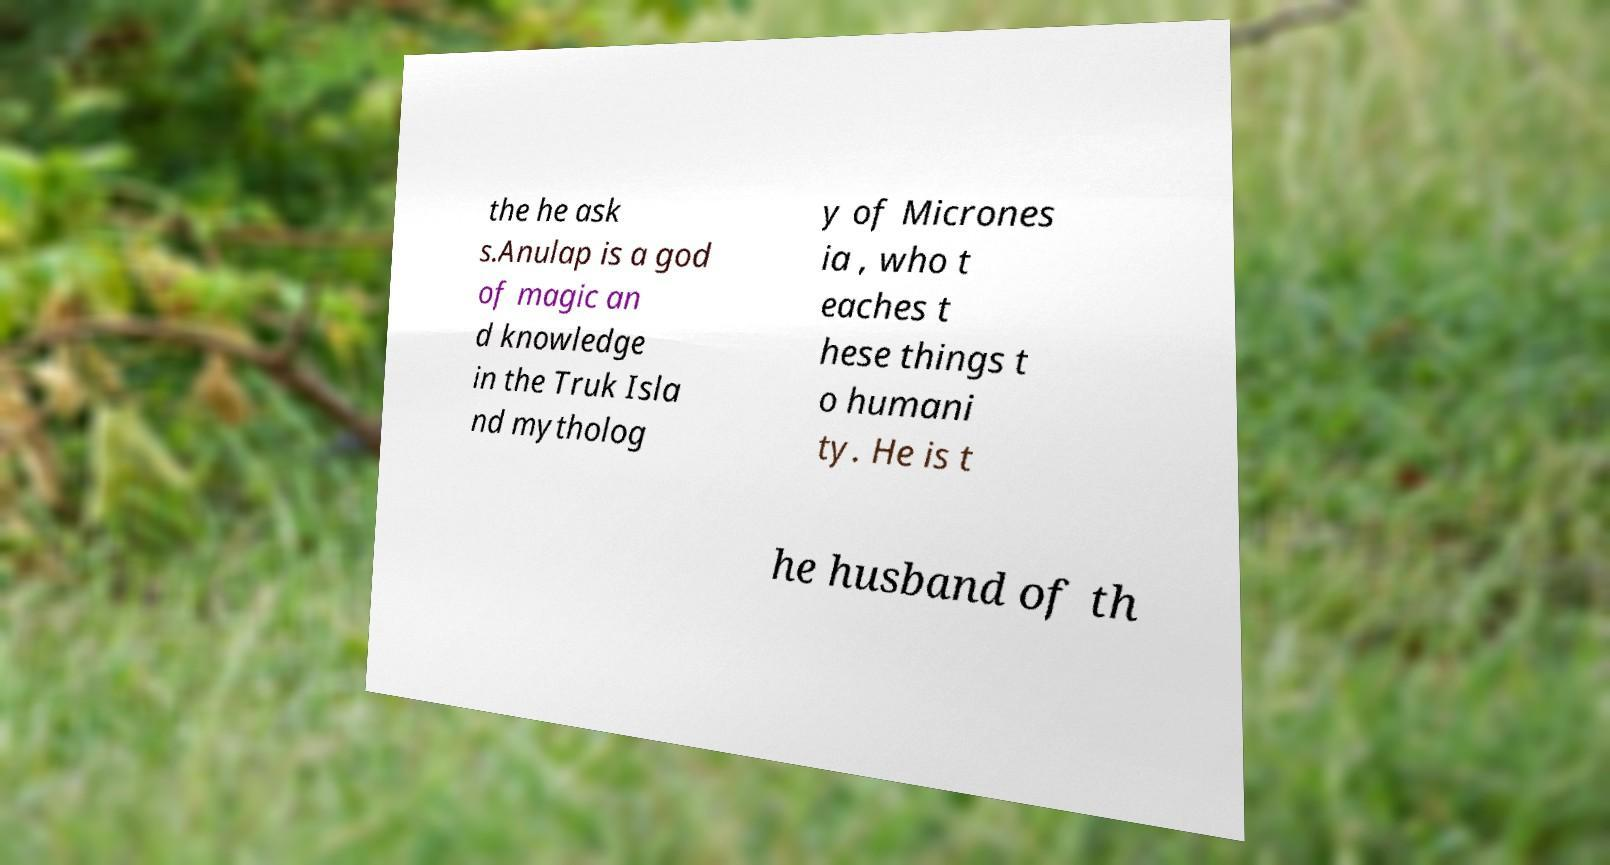Can you read and provide the text displayed in the image?This photo seems to have some interesting text. Can you extract and type it out for me? the he ask s.Anulap is a god of magic an d knowledge in the Truk Isla nd mytholog y of Micrones ia , who t eaches t hese things t o humani ty. He is t he husband of th 